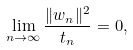<formula> <loc_0><loc_0><loc_500><loc_500>\lim _ { n \to \infty } \frac { \| w _ { n } \| ^ { 2 } } { t _ { n } } = 0 ,</formula> 